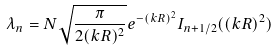Convert formula to latex. <formula><loc_0><loc_0><loc_500><loc_500>\lambda _ { n } = N \sqrt { \frac { \pi } { 2 ( k R ) ^ { 2 } } } e ^ { - ( k R ) ^ { 2 } } I _ { n + 1 / 2 } ( ( k R ) ^ { 2 } )</formula> 